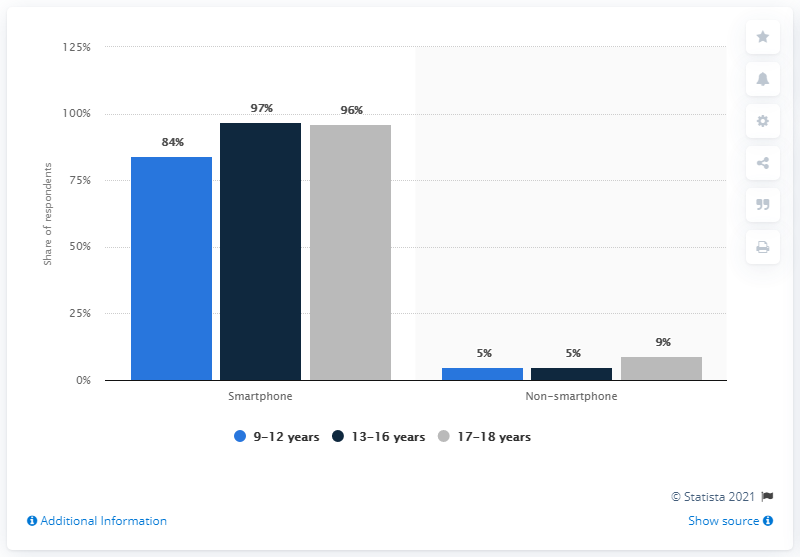Draw attention to some important aspects in this diagram. The ownership rate of smartphones among teenagers between the ages of 13 and 16 was 97%. A recent survey revealed that 97% of children in the same age group owned phones. 